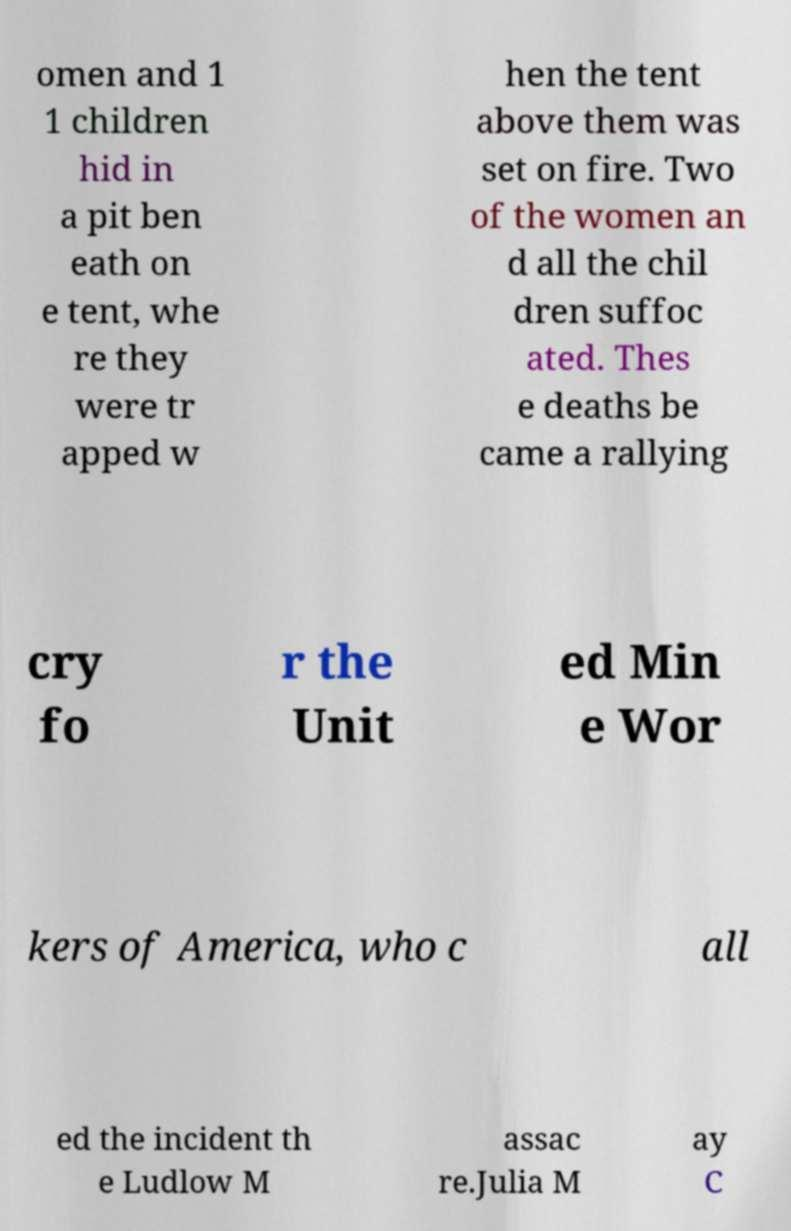What messages or text are displayed in this image? I need them in a readable, typed format. omen and 1 1 children hid in a pit ben eath on e tent, whe re they were tr apped w hen the tent above them was set on fire. Two of the women an d all the chil dren suffoc ated. Thes e deaths be came a rallying cry fo r the Unit ed Min e Wor kers of America, who c all ed the incident th e Ludlow M assac re.Julia M ay C 